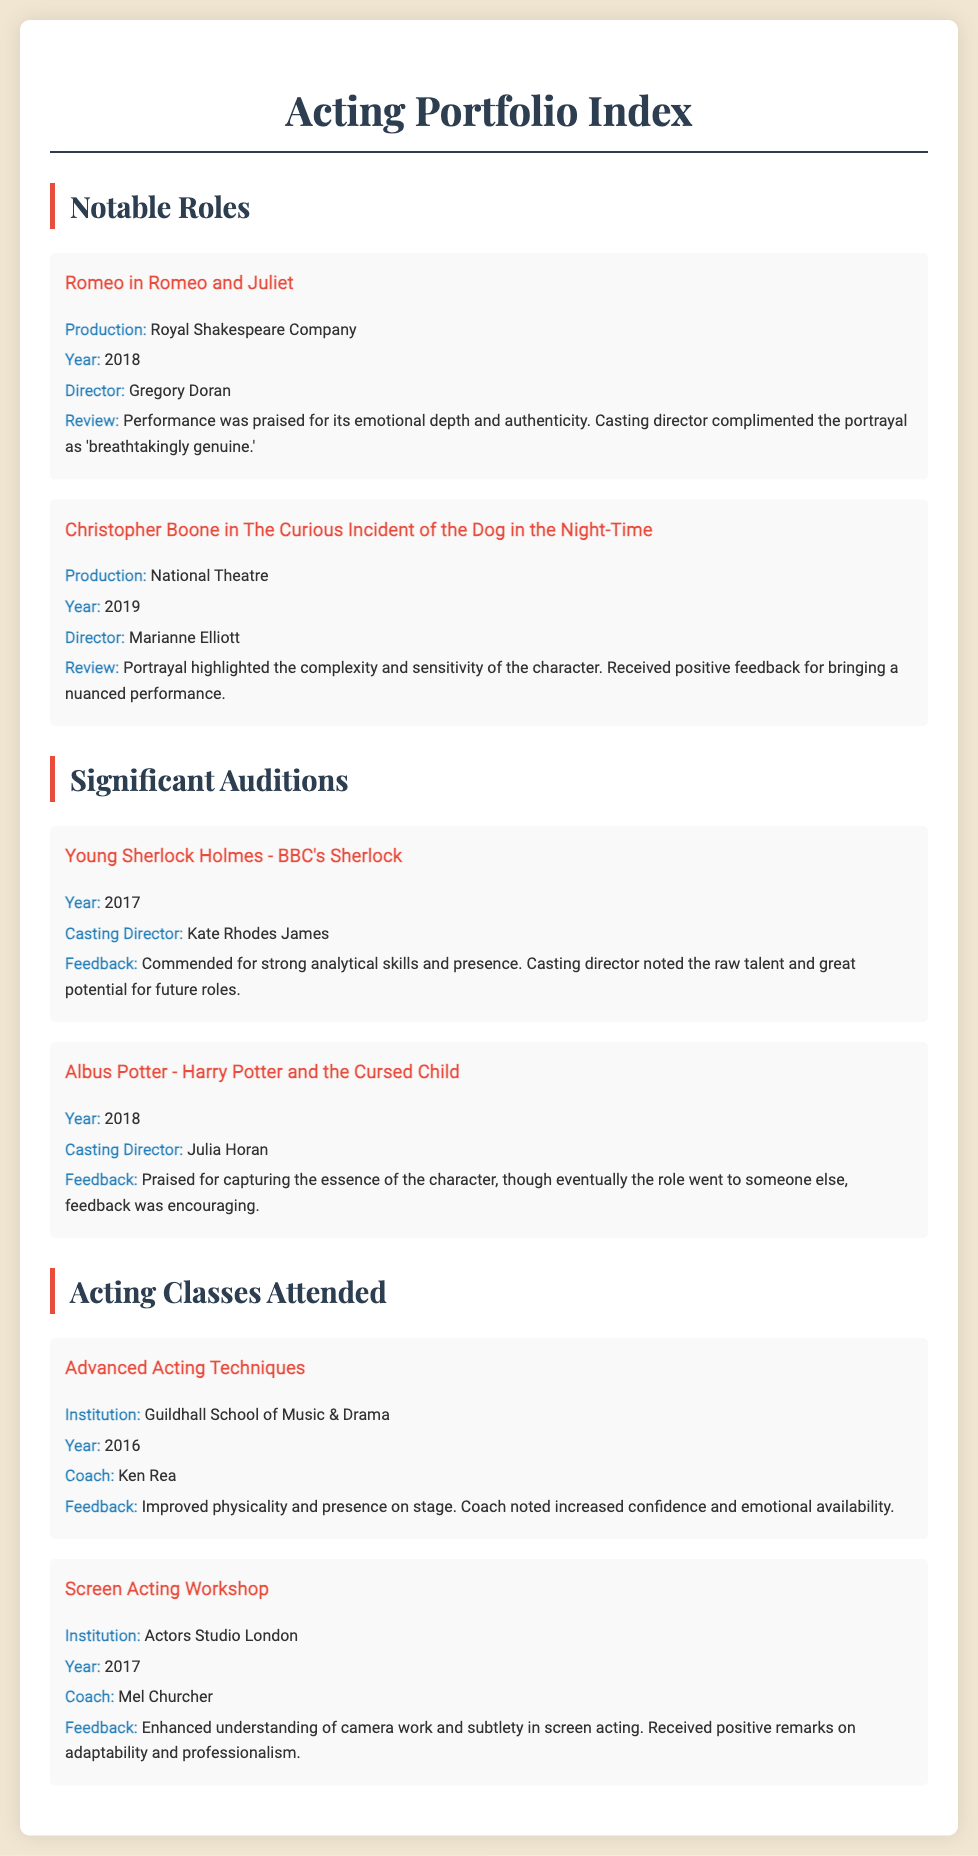What role did you play in 2018? The document lists the notable roles the actor played, including "Romeo in Romeo and Juliet" in 2018.
Answer: Romeo in Romeo and Juliet Who directed "The Curious Incident of the Dog in the Night-Time"? The document provides information about the productions, including the director of "The Curious Incident of the Dog in the Night-Time," which was Marianne Elliott.
Answer: Marianne Elliott What year was the audition for Young Sherlock Holmes? The audition years are listed, with Young Sherlock Holmes auditioned in 2017.
Answer: 2017 Which institution hosted the Advanced Acting Techniques class? The document specifies institutions for acting classes, stating that the Advanced Acting Techniques class was at the Guildhall School of Music & Drama.
Answer: Guildhall School of Music & Drama What feedback was given for the audition of Albus Potter? The document contains feedback on auditions, which for Albus Potter included praise for capturing the essence of the character.
Answer: Praised for capturing the essence of the character What notable production did you perform in under director Gregory Doran? The document features notable roles and specifies that director Gregory Doran directed "Romeo and Juliet."
Answer: Romeo and Juliet How many significant auditions are mentioned in the document? The document lists significant auditions, where two auditions are explicitly mentioned.
Answer: Two What class did the actor take in 2017? The document lists acting classes, one of which was the "Screen Acting Workshop" in 2017.
Answer: Screen Acting Workshop What was improved in the Advanced Acting Techniques class according to feedback? The feedback section of the document mentions improvements in physicality and presence on stage from the class.
Answer: Physicality and presence on stage 